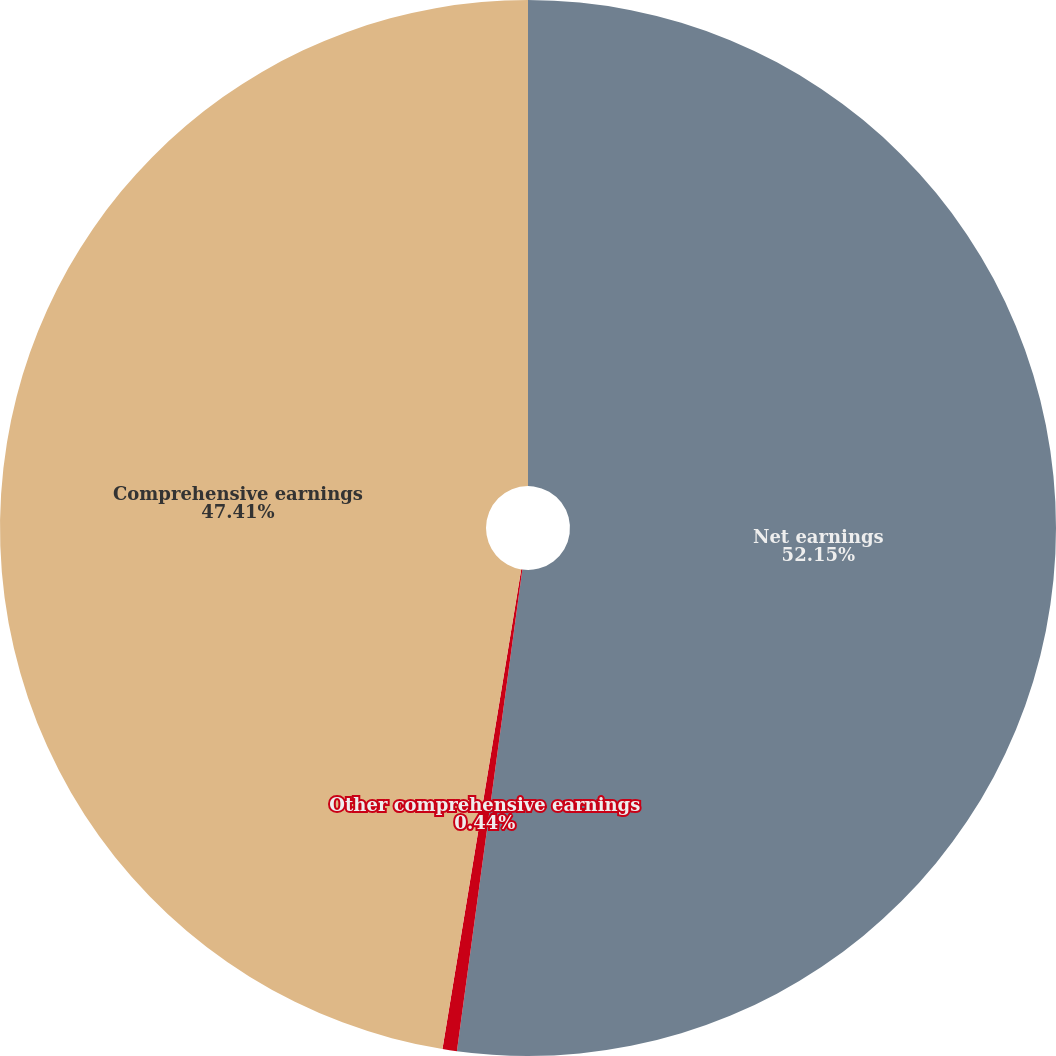Convert chart to OTSL. <chart><loc_0><loc_0><loc_500><loc_500><pie_chart><fcel>Net earnings<fcel>Other comprehensive earnings<fcel>Comprehensive earnings<nl><fcel>52.15%<fcel>0.44%<fcel>47.41%<nl></chart> 